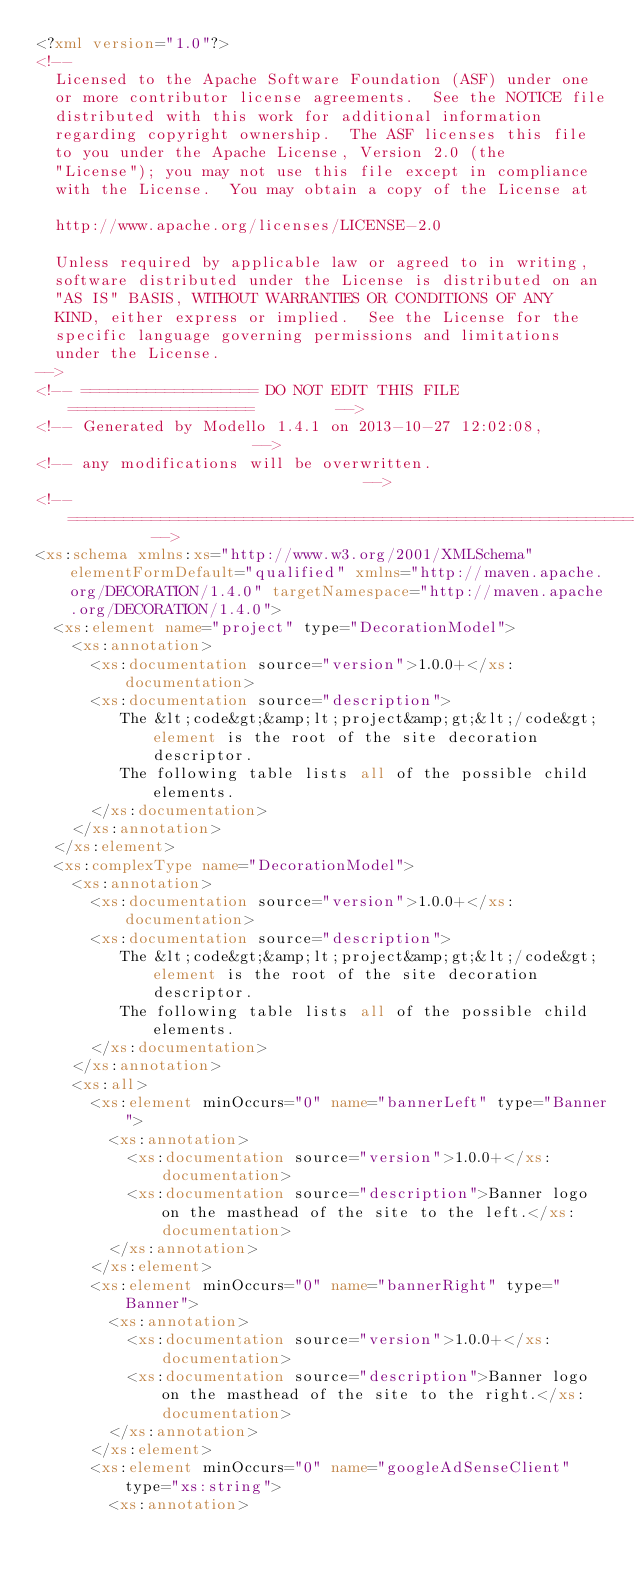Convert code to text. <code><loc_0><loc_0><loc_500><loc_500><_XML_><?xml version="1.0"?>
<!--
  Licensed to the Apache Software Foundation (ASF) under one
  or more contributor license agreements.  See the NOTICE file
  distributed with this work for additional information
  regarding copyright ownership.  The ASF licenses this file
  to you under the Apache License, Version 2.0 (the
  "License"); you may not use this file except in compliance
  with the License.  You may obtain a copy of the License at

  http://www.apache.org/licenses/LICENSE-2.0

  Unless required by applicable law or agreed to in writing,
  software distributed under the License is distributed on an
  "AS IS" BASIS, WITHOUT WARRANTIES OR CONDITIONS OF ANY
  KIND, either express or implied.  See the License for the
  specific language governing permissions and limitations
  under the License.
-->
<!-- =================== DO NOT EDIT THIS FILE ====================         -->
<!-- Generated by Modello 1.4.1 on 2013-10-27 12:02:08,                     -->
<!-- any modifications will be overwritten.                                 -->
<!-- ==============================================================         -->
<xs:schema xmlns:xs="http://www.w3.org/2001/XMLSchema" elementFormDefault="qualified" xmlns="http://maven.apache.org/DECORATION/1.4.0" targetNamespace="http://maven.apache.org/DECORATION/1.4.0">
  <xs:element name="project" type="DecorationModel">
    <xs:annotation>
      <xs:documentation source="version">1.0.0+</xs:documentation>
      <xs:documentation source="description">
         The &lt;code&gt;&amp;lt;project&amp;gt;&lt;/code&gt; element is the root of the site decoration descriptor.
         The following table lists all of the possible child elements.
      </xs:documentation>
    </xs:annotation>
  </xs:element>
  <xs:complexType name="DecorationModel">
    <xs:annotation>
      <xs:documentation source="version">1.0.0+</xs:documentation>
      <xs:documentation source="description">
         The &lt;code&gt;&amp;lt;project&amp;gt;&lt;/code&gt; element is the root of the site decoration descriptor.
         The following table lists all of the possible child elements.
      </xs:documentation>
    </xs:annotation>
    <xs:all>
      <xs:element minOccurs="0" name="bannerLeft" type="Banner">
        <xs:annotation>
          <xs:documentation source="version">1.0.0+</xs:documentation>
          <xs:documentation source="description">Banner logo on the masthead of the site to the left.</xs:documentation>
        </xs:annotation>
      </xs:element>
      <xs:element minOccurs="0" name="bannerRight" type="Banner">
        <xs:annotation>
          <xs:documentation source="version">1.0.0+</xs:documentation>
          <xs:documentation source="description">Banner logo on the masthead of the site to the right.</xs:documentation>
        </xs:annotation>
      </xs:element>
      <xs:element minOccurs="0" name="googleAdSenseClient" type="xs:string">
        <xs:annotation></code> 